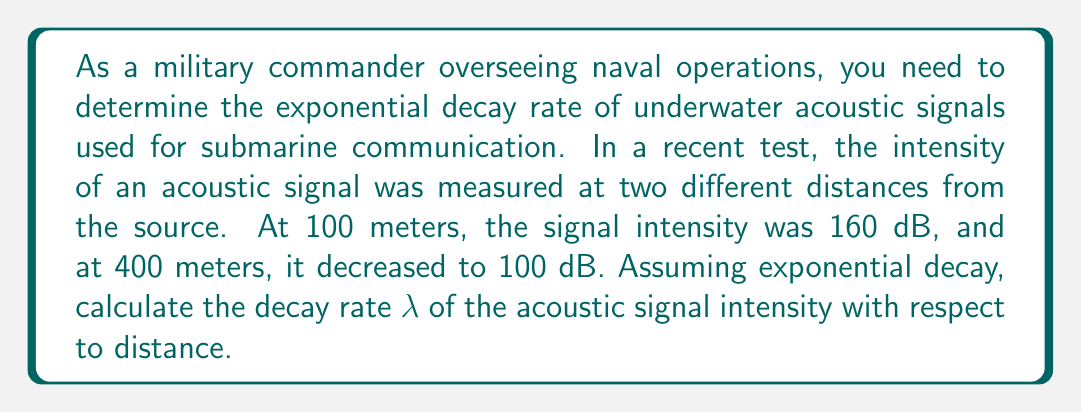Provide a solution to this math problem. To solve this problem, we'll use the exponential decay formula:

$$ I(x) = I_0 e^{-λx} $$

Where:
$I(x)$ is the intensity at distance $x$
$I_0$ is the initial intensity
$λ$ is the decay rate
$x$ is the distance

We have two data points:
1. At $x_1 = 100$ m, $I(x_1) = 160$ dB
2. At $x_2 = 400$ m, $I(x_2) = 100$ dB

Let's use these points to set up two equations:

$$ 160 = I_0 e^{-λ(100)} $$
$$ 100 = I_0 e^{-λ(400)} $$

Dividing the second equation by the first:

$$ \frac{100}{160} = \frac{I_0 e^{-λ(400)}}{I_0 e^{-λ(100)}} $$

The $I_0$ terms cancel out:

$$ \frac{5}{8} = \frac{e^{-400λ}}{e^{-100λ}} = e^{-300λ} $$

Taking the natural logarithm of both sides:

$$ \ln(\frac{5}{8}) = -300λ $$

Solving for λ:

$$ λ = -\frac{\ln(\frac{5}{8})}{300} $$

$$ λ = \frac{\ln(\frac{8}{5})}{300} ≈ 0.001551 \text{ m}^{-1} $$

This decay rate λ represents the fractional decrease in signal intensity per meter of distance traveled.
Answer: $λ ≈ 0.001551 \text{ m}^{-1}$ 